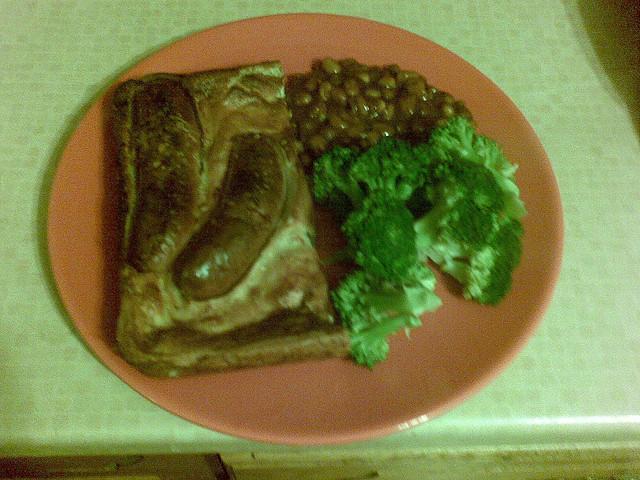Does the plate have room for more?
Short answer required. No. What color is the bowl?
Give a very brief answer. Pink. What is the color of the plate?
Quick response, please. Orange. Is there broccoli?
Concise answer only. Yes. 